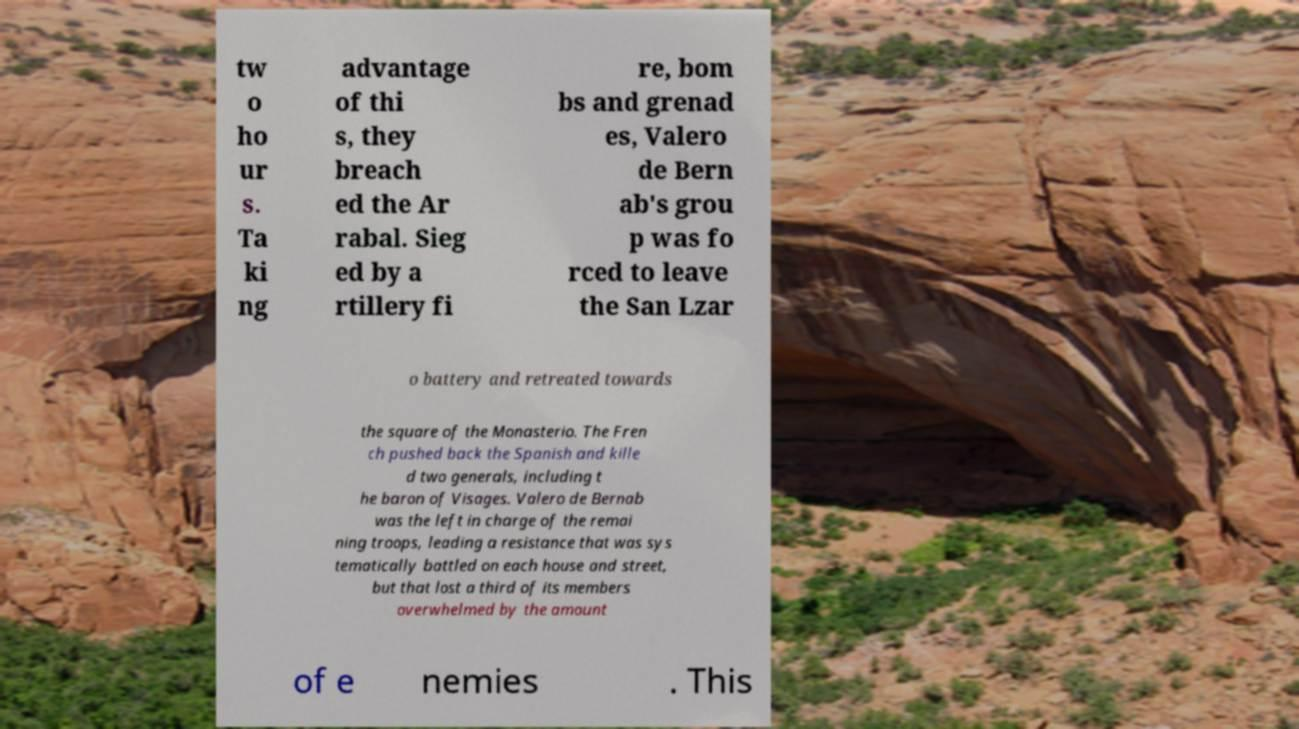Could you assist in decoding the text presented in this image and type it out clearly? tw o ho ur s. Ta ki ng advantage of thi s, they breach ed the Ar rabal. Sieg ed by a rtillery fi re, bom bs and grenad es, Valero de Bern ab's grou p was fo rced to leave the San Lzar o battery and retreated towards the square of the Monasterio. The Fren ch pushed back the Spanish and kille d two generals, including t he baron of Visages. Valero de Bernab was the left in charge of the remai ning troops, leading a resistance that was sys tematically battled on each house and street, but that lost a third of its members overwhelmed by the amount of e nemies . This 